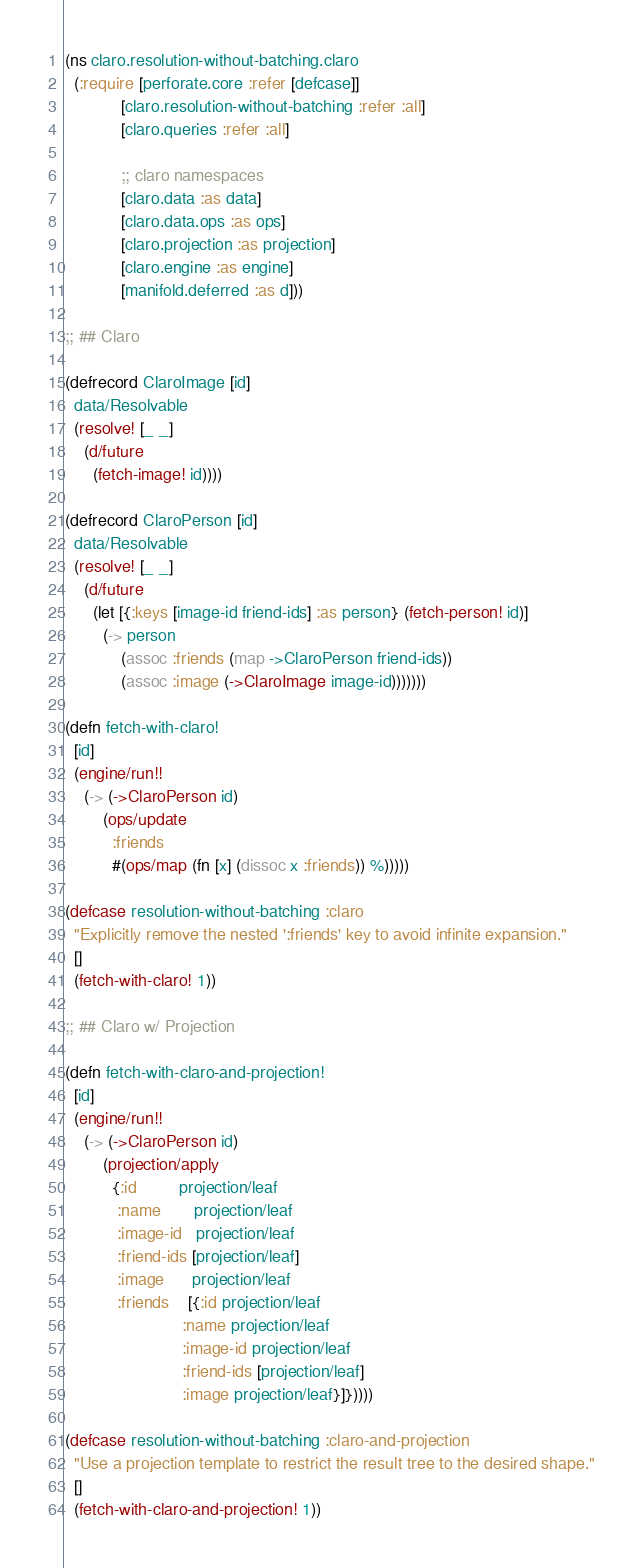Convert code to text. <code><loc_0><loc_0><loc_500><loc_500><_Clojure_>(ns claro.resolution-without-batching.claro
  (:require [perforate.core :refer [defcase]]
            [claro.resolution-without-batching :refer :all]
            [claro.queries :refer :all]

            ;; claro namespaces
            [claro.data :as data]
            [claro.data.ops :as ops]
            [claro.projection :as projection]
            [claro.engine :as engine]
            [manifold.deferred :as d]))

;; ## Claro

(defrecord ClaroImage [id]
  data/Resolvable
  (resolve! [_ _]
    (d/future
      (fetch-image! id))))

(defrecord ClaroPerson [id]
  data/Resolvable
  (resolve! [_ _]
    (d/future
      (let [{:keys [image-id friend-ids] :as person} (fetch-person! id)]
        (-> person
            (assoc :friends (map ->ClaroPerson friend-ids))
            (assoc :image (->ClaroImage image-id)))))))

(defn fetch-with-claro!
  [id]
  (engine/run!!
    (-> (->ClaroPerson id)
        (ops/update
          :friends
          #(ops/map (fn [x] (dissoc x :friends)) %)))))

(defcase resolution-without-batching :claro
  "Explicitly remove the nested ':friends' key to avoid infinite expansion."
  []
  (fetch-with-claro! 1))

;; ## Claro w/ Projection

(defn fetch-with-claro-and-projection!
  [id]
  (engine/run!!
    (-> (->ClaroPerson id)
        (projection/apply
          {:id         projection/leaf
           :name       projection/leaf
           :image-id   projection/leaf
           :friend-ids [projection/leaf]
           :image      projection/leaf
           :friends    [{:id projection/leaf
                         :name projection/leaf
                         :image-id projection/leaf
                         :friend-ids [projection/leaf]
                         :image projection/leaf}]}))))

(defcase resolution-without-batching :claro-and-projection
  "Use a projection template to restrict the result tree to the desired shape."
  []
  (fetch-with-claro-and-projection! 1))
</code> 